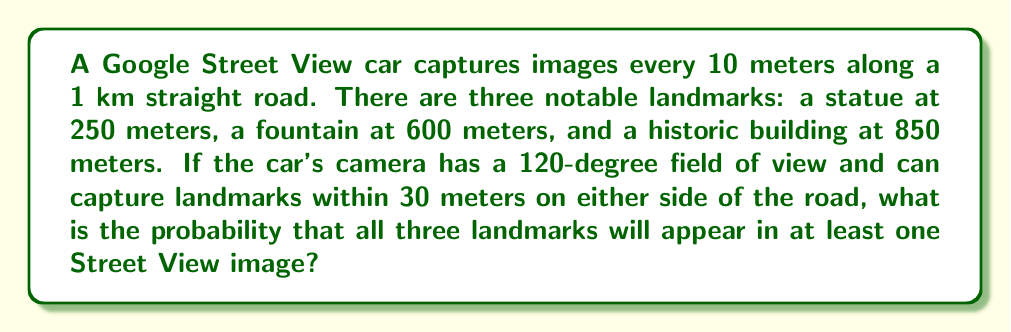Solve this math problem. Let's approach this step-by-step:

1) First, we need to calculate the range in which each landmark can be captured:
   - For each landmark, it can be captured 30 meters before and 30 meters after its position.
   - So, each landmark has a 60-meter range where it can be captured.

2) Now, let's calculate the number of image capture points for each landmark:
   - Statue (250m): From 220m to 280m
   - Fountain (600m): From 570m to 630m
   - Historic building (850m): From 820m to 880m

3) Since images are captured every 10 meters, the number of capture points for each landmark is:
   $$ \text{Capture points} = \frac{60\text{m}}{10\text{m/capture}} + 1 = 7 $$
   (We add 1 because both endpoints are included)

4) The probability of capturing a landmark in at least one image is:
   $$ P(\text{captured}) = 1 - P(\text{not captured}) $$
   $$ P(\text{not captured}) = \left(\frac{100 - 7}{100}\right) = 0.93 $$
   $$ P(\text{captured}) = 1 - 0.93 = 0.07 $$

5) For all three landmarks to be captured, we need the probability of all three events occurring:
   $$ P(\text{all captured}) = 0.07 * 0.07 * 0.07 = 0.000343 $$

6) Therefore, the probability that all three landmarks will appear in at least one Street View image is 0.000343 or about 0.0343%.
Answer: 0.000343 